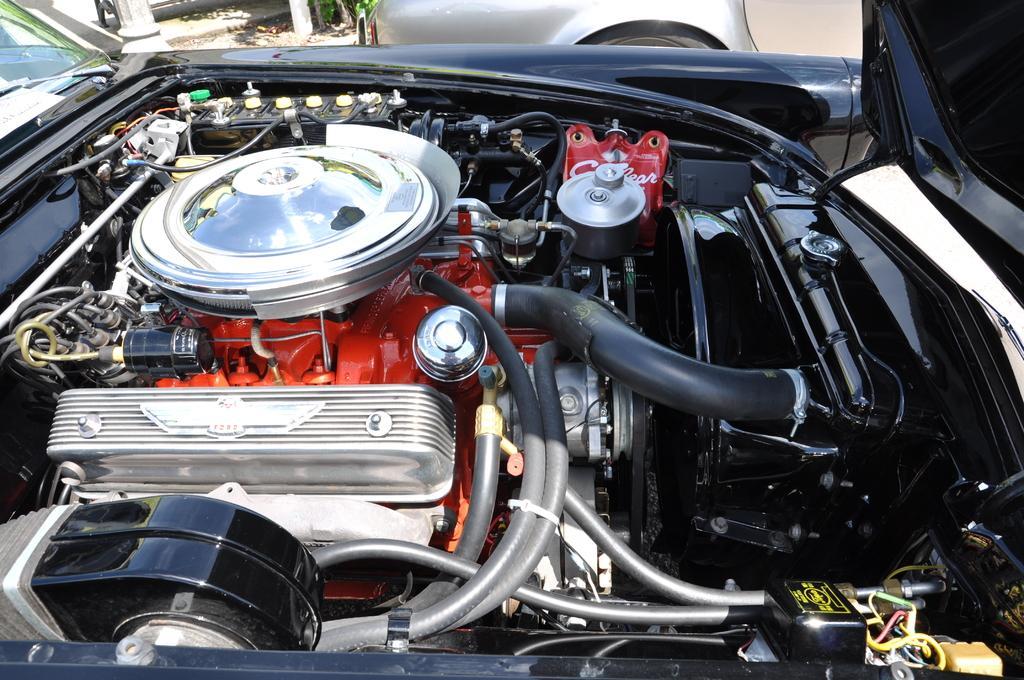Could you give a brief overview of what you see in this image? In this image we can see the engine of a motor vehicle. 